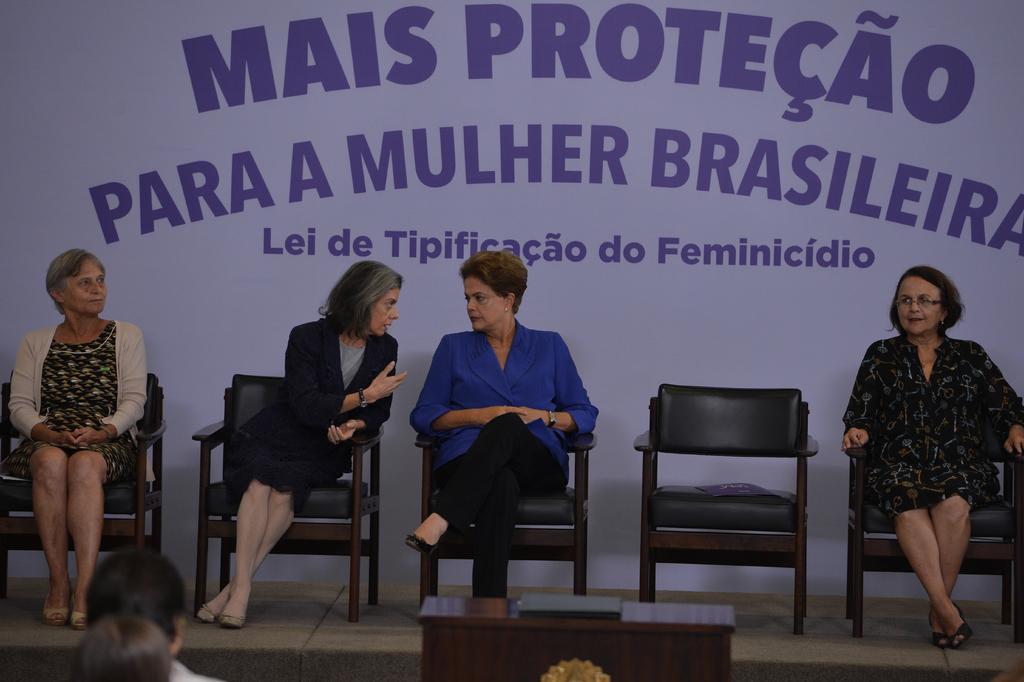Can you describe this image briefly? In this picture there are four women sitting in chairs and there is an unoccupied chair on the stage. A poster with MAIS PROTECAO written on it. 